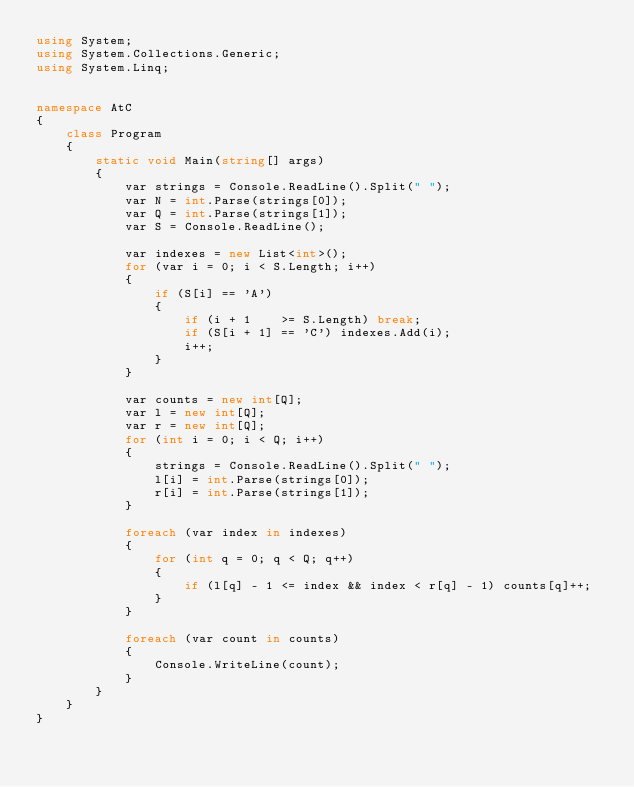<code> <loc_0><loc_0><loc_500><loc_500><_C#_>using System;
using System.Collections.Generic;
using System.Linq;


namespace AtC
{
    class Program
    {
        static void Main(string[] args)
        {
            var strings = Console.ReadLine().Split(" ");
            var N = int.Parse(strings[0]);
            var Q = int.Parse(strings[1]);
            var S = Console.ReadLine();

            var indexes = new List<int>();
            for (var i = 0; i < S.Length; i++)
            {
                if (S[i] == 'A')
                {
                    if (i + 1    >= S.Length) break;
                    if (S[i + 1] == 'C') indexes.Add(i);
                    i++;
                }
            }

            var counts = new int[Q];
            var l = new int[Q];
            var r = new int[Q];
            for (int i = 0; i < Q; i++)
            {
                strings = Console.ReadLine().Split(" ");
                l[i] = int.Parse(strings[0]);
                r[i] = int.Parse(strings[1]);
            }

            foreach (var index in indexes)
            {
                for (int q = 0; q < Q; q++)
                {
                    if (l[q] - 1 <= index && index < r[q] - 1) counts[q]++;
                }
            }

            foreach (var count in counts)
            {
                Console.WriteLine(count);
            }
        }
    }
}</code> 